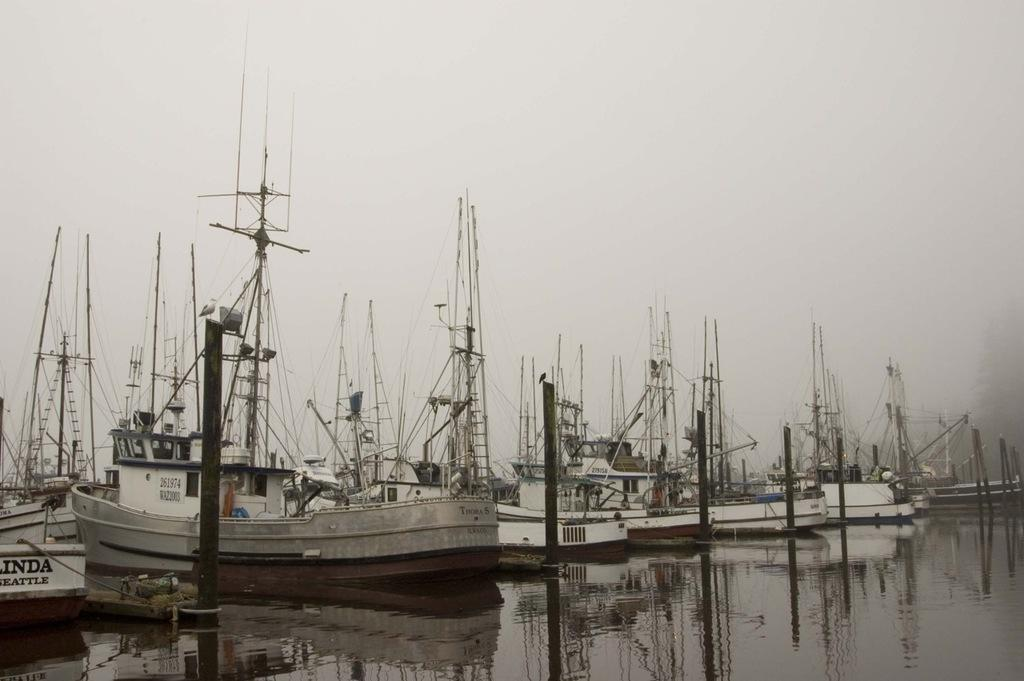<image>
Provide a brief description of the given image. A number of boats in the harbor including one called Thora S. 